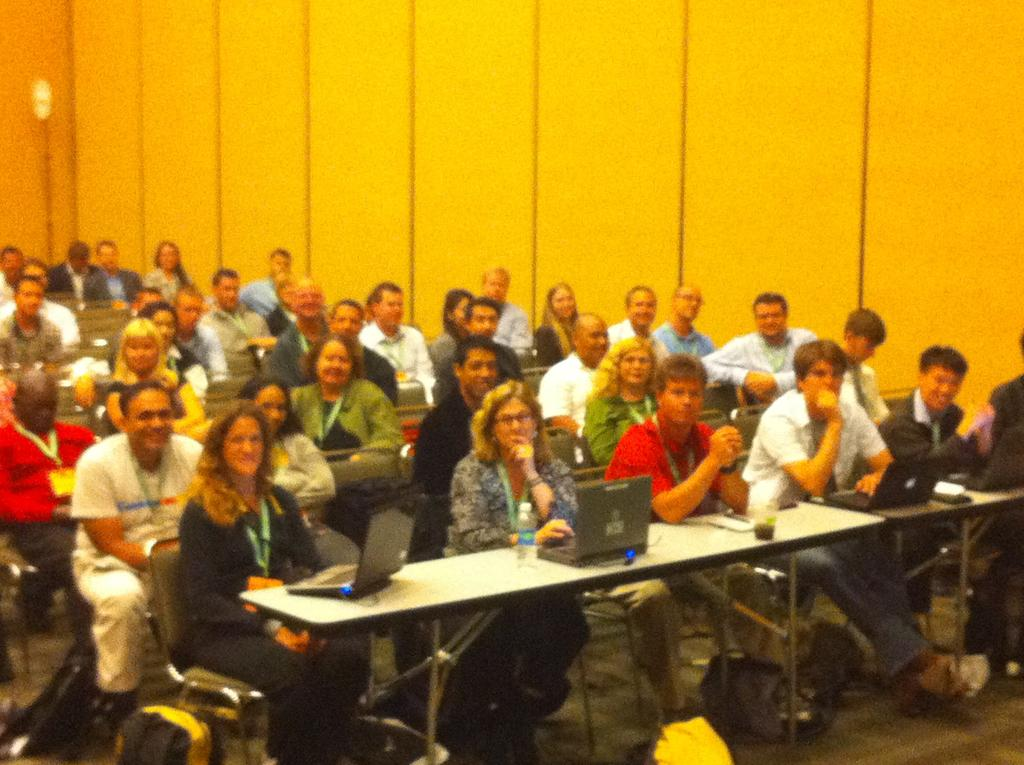What are the seated persons doing in the image? The seated persons are sitting in chairs. What is in front of the seated persons? There is a table in front of the seated persons. What objects can be seen on the table? There are laptops on the table. Can you describe the arrangement of the persons in the image? There are other persons sitting behind the seated persons. What type of root can be seen growing from the laptops in the image? There are no roots visible in the image, as the laptops are on a table and not in a natural environment. 